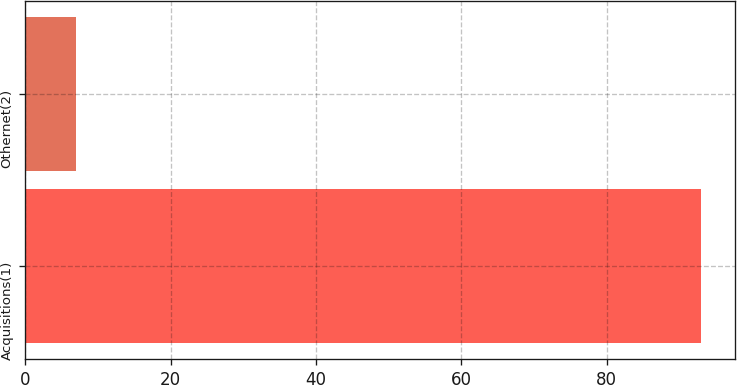Convert chart. <chart><loc_0><loc_0><loc_500><loc_500><bar_chart><fcel>Acquisitions(1)<fcel>Othernet(2)<nl><fcel>93<fcel>7<nl></chart> 